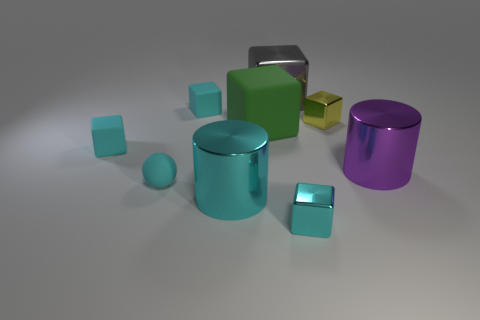The tiny shiny object that is the same color as the ball is what shape?
Provide a short and direct response. Cube. There is a large object that is the same color as the rubber ball; what is its material?
Offer a very short reply. Metal. What is the size of the yellow object that is made of the same material as the gray cube?
Provide a short and direct response. Small. What is the object that is to the left of the gray cube and in front of the tiny sphere made of?
Provide a short and direct response. Metal. What number of cylinders have the same size as the green rubber thing?
Offer a very short reply. 2. What material is the large gray thing that is the same shape as the tiny yellow object?
Offer a terse response. Metal. How many objects are large metal cylinders that are to the left of the big metallic block or small cyan cubes that are to the right of the large cyan metal cylinder?
Provide a short and direct response. 2. There is a large gray metal thing; does it have the same shape as the tiny cyan object that is to the right of the gray shiny cube?
Your answer should be very brief. Yes. There is a tiny matte thing that is in front of the object on the left side of the tiny matte thing in front of the big purple object; what shape is it?
Offer a terse response. Sphere. How many other things are the same material as the green thing?
Make the answer very short. 3. 